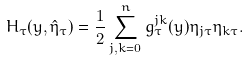Convert formula to latex. <formula><loc_0><loc_0><loc_500><loc_500>H _ { \tau } ( y , \hat { \eta } _ { \tau } ) = \frac { 1 } { 2 } \sum _ { j , k = 0 } ^ { n } g _ { \tau } ^ { j k } ( y ) \eta _ { j \tau } \eta _ { k \tau } .</formula> 